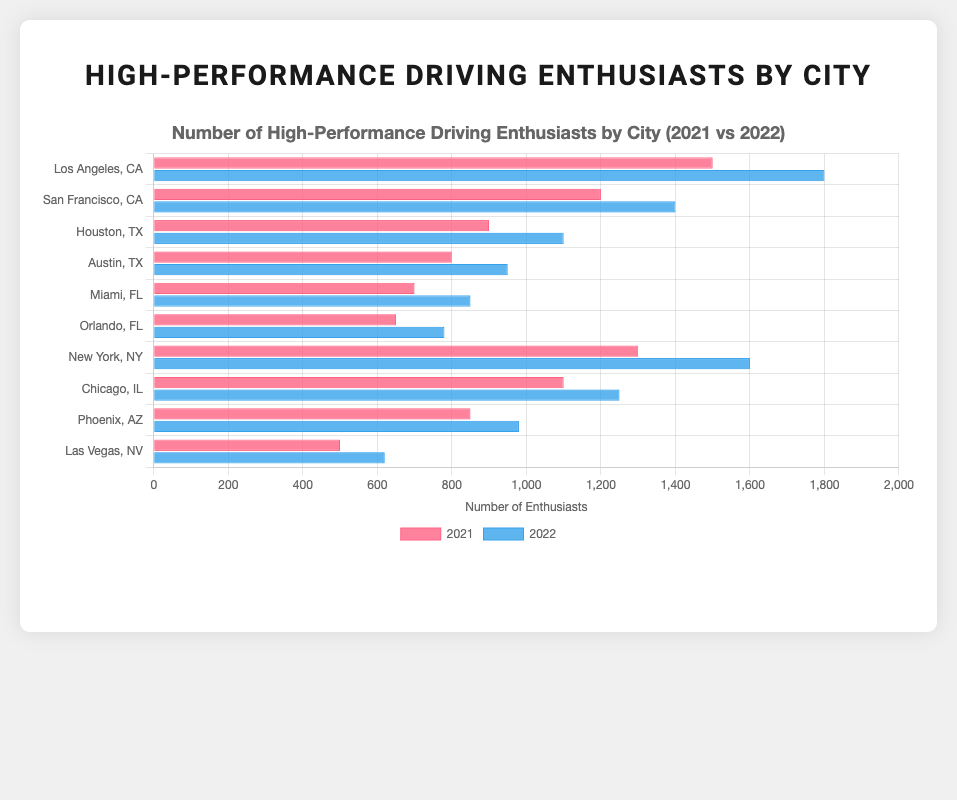Which city had the highest number of high-performance driving enthusiasts in 2022? According to the plotted data, Los Angeles, CA, had the highest number of enthusiasts in 2022 with 1800 enthusiasts, followed closely by New York, NY with 1600 enthusiasts.
Answer: Los Angeles, CA What is the difference in the number of enthusiasts between Los Angeles, CA, and Houston, TX in 2022? The number of enthusiasts in Los Angeles in 2022 was 1800, while in Houston, it was 1100. The difference is computed as 1800 - 1100.
Answer: 700 Which cities saw an increase in enthusiasts from 2021 to 2022? By comparing the number of enthusiasts between 2021 and 2022 for each city, one can see that all listed cities saw an increase in enthusiasts: Los Angeles, San Francisco, Houston, Austin, Miami, Orlando, New York, Chicago, Phoenix, and Las Vegas.
Answer: All listed cities Among the listed cities, which one had the smallest number of enthusiasts in 2021? By visually comparing the height of the 2021 bars, Las Vegas, NV, had the smallest number of enthusiasts in 2021 with 500 enthusiasts.
Answer: Las Vegas, NV What was the total number of high-performance driving enthusiasts in California (Los Angeles and San Francisco) in 2022? Adding up the number of enthusiasts in Los Angeles (1800) and San Francisco (1400) in 2022 results in a total of 1800 + 1400.
Answer: 3200 Which city had the smaller increase in the number of enthusiasts from 2021 to 2022: Orlando, FL, or Austin, TX? Orlando, FL, increased from 650 to 780 (a difference of 130), while Austin, TX, increased from 800 to 950 (a difference of 150). Thus, Orlando had the smaller increase.
Answer: Orlando, FL Which state has a higher combined number of enthusiasts in 2022: Florida (Miami and Orlando) or Texas (Houston and Austin)? Summing the number of enthusiasts in Florida's cities (Miami: 850, Orlando: 780) gives 1630; whereas in Texas's cities (Houston: 1100, Austin: 950) it gives 2050. Hence, Texas has a higher combined number.
Answer: Texas How does the number of enthusiasts in New York, NY compare between 2021 and 2022? New York had 1300 enthusiasts in 2021 and 1600 in 2022, showing an increase of 1600 - 1300 enthusiasts from 2021 to 2022.
Answer: Increased by 300 Visually, which city shows the largest bar for the year 2021? The largest bar for the year 2021 by visual inspection is for Los Angeles, CA, as it reaches the highest point compared to other bars for the year 2021.
Answer: Los Angeles, CA 